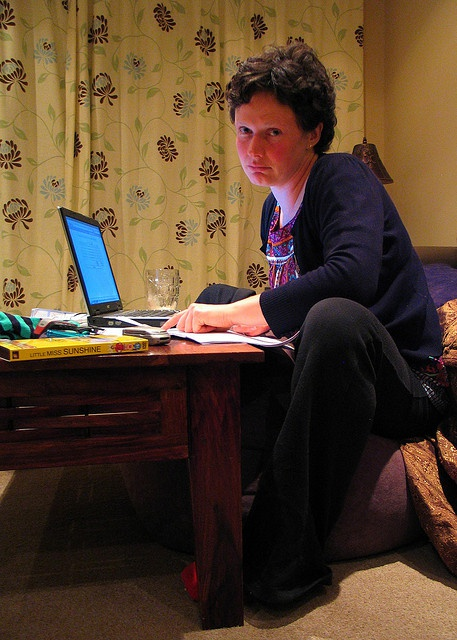Describe the objects in this image and their specific colors. I can see people in darkgreen, black, maroon, brown, and navy tones, chair in darkgreen, black, maroon, and brown tones, laptop in darkgreen, lightblue, black, and white tones, book in darkgreen, olive, gold, and white tones, and cup in darkgreen and tan tones in this image. 